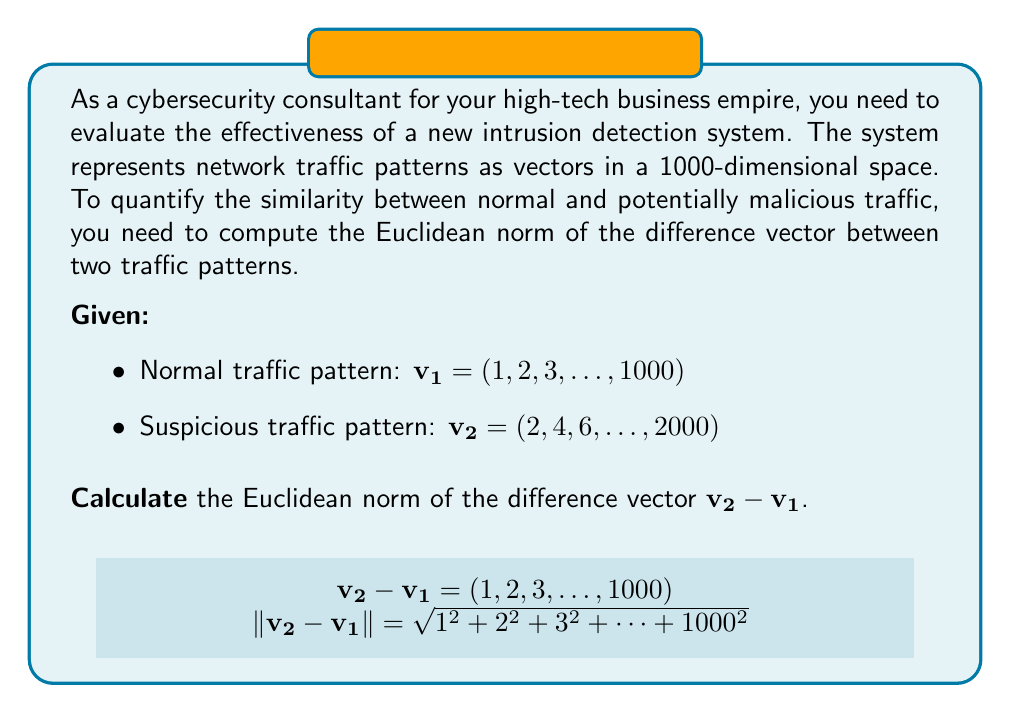Show me your answer to this math problem. Let's approach this step-by-step:

1) First, we need to find the difference vector $\mathbf{v_2 - v_1}$:
   $\mathbf{v_2 - v_1} = (2-1, 4-2, 6-3, ..., 2000-1000) = (1, 2, 3, ..., 1000)$

2) The Euclidean norm of a vector $\mathbf{x} = (x_1, x_2, ..., x_n)$ is defined as:
   $$\|\mathbf{x}\| = \sqrt{\sum_{i=1}^n x_i^2}$$

3) In our case, we need to calculate:
   $$\|\mathbf{v_2 - v_1}\| = \sqrt{1^2 + 2^2 + 3^2 + ... + 1000^2}$$

4) This sum has a special form. The sum of squares of first n natural numbers is given by the formula:
   $$\sum_{i=1}^n i^2 = \frac{n(n+1)(2n+1)}{6}$$

5) In our case, $n = 1000$, so:
   $$\|\mathbf{v_2 - v_1}\| = \sqrt{\frac{1000(1001)(2001)}{6}}$$

6) Simplifying:
   $$\|\mathbf{v_2 - v_1}\| = \sqrt{333833500} = 18270$$

This value represents the magnitude of the difference between the normal and suspicious traffic patterns in your 1000-dimensional space.
Answer: $18270$ 